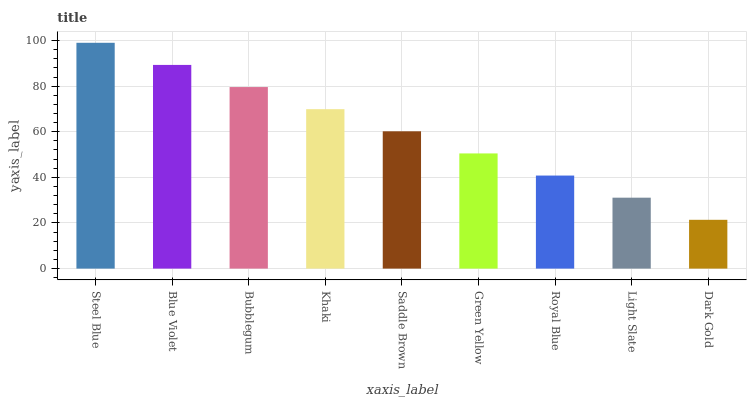Is Dark Gold the minimum?
Answer yes or no. Yes. Is Steel Blue the maximum?
Answer yes or no. Yes. Is Blue Violet the minimum?
Answer yes or no. No. Is Blue Violet the maximum?
Answer yes or no. No. Is Steel Blue greater than Blue Violet?
Answer yes or no. Yes. Is Blue Violet less than Steel Blue?
Answer yes or no. Yes. Is Blue Violet greater than Steel Blue?
Answer yes or no. No. Is Steel Blue less than Blue Violet?
Answer yes or no. No. Is Saddle Brown the high median?
Answer yes or no. Yes. Is Saddle Brown the low median?
Answer yes or no. Yes. Is Khaki the high median?
Answer yes or no. No. Is Blue Violet the low median?
Answer yes or no. No. 